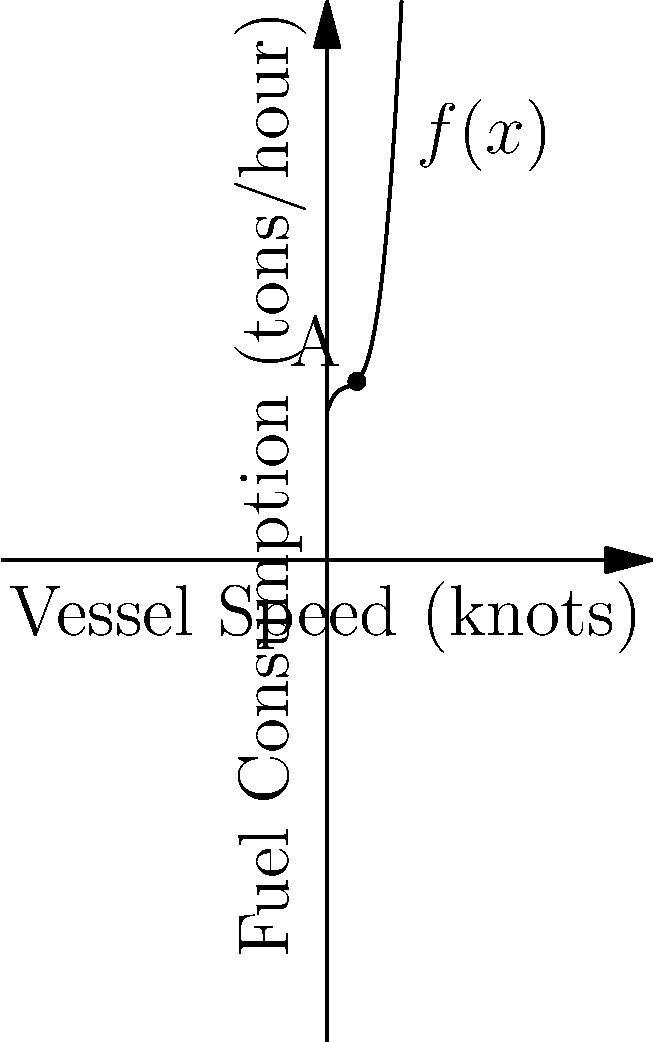The graph shows the fuel consumption $f(x)$ in tons per hour for a cargo ship as a function of its speed $x$ in knots. At point A, where the speed is 2 knots, what is the instantaneous rate of change of fuel consumption with respect to speed? How does this relate to the efforts of reducing environmental impact from shipping? To solve this problem, we need to follow these steps:

1) The instantaneous rate of change of fuel consumption with respect to speed is given by the derivative of the function $f(x)$ at the point $x=2$.

2) From the graph, we can see that $f(x)$ is a cubic function. Let's assume it has the general form:

   $f(x) = ax^3 + bx^2 + cx + d$

3) The derivative of this function is:

   $f'(x) = 3ax^2 + 2bx + c$

4) To find the specific values of $a$, $b$, and $c$, we would need more information. However, we can see from the graph that at $x=2$, the slope of the tangent line (which represents $f'(2)$) is positive and relatively small.

5) If we had the exact function, we could plug in $x=2$ to get the precise value of $f'(2)$.

6) Relating this to environmental impact: The rate of change of fuel consumption with respect to speed is crucial for optimizing vessel operations. A positive slope at this point means that increasing speed leads to higher fuel consumption, which in turn increases emissions. By understanding this relationship, ship operators can choose optimal speeds to minimize fuel consumption and reduce their environmental footprint.

7) Machine learning models could be developed to predict and optimize this relationship across different vessels and operating conditions, potentially leading to significant reductions in maritime emissions.
Answer: $f'(2)$ is positive and small; exact value depends on specific function coefficients. This represents the marginal increase in fuel consumption as speed increases, crucial for minimizing environmental impact. 